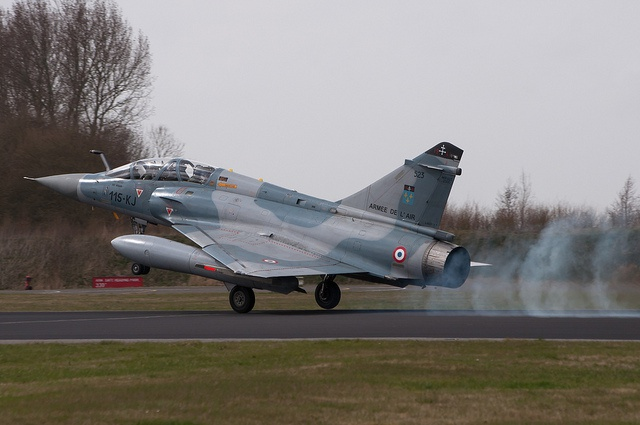Describe the objects in this image and their specific colors. I can see airplane in lightgray, darkgray, gray, and black tones and people in lightgray, gray, and black tones in this image. 